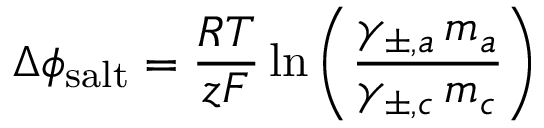Convert formula to latex. <formula><loc_0><loc_0><loc_500><loc_500>\Delta \phi _ { s a l t } = \frac { R T } { z F } \ln \left ( \frac { \gamma _ { \pm , a } \, m _ { a } } { \gamma _ { \pm , c } \, m _ { c } } \right )</formula> 